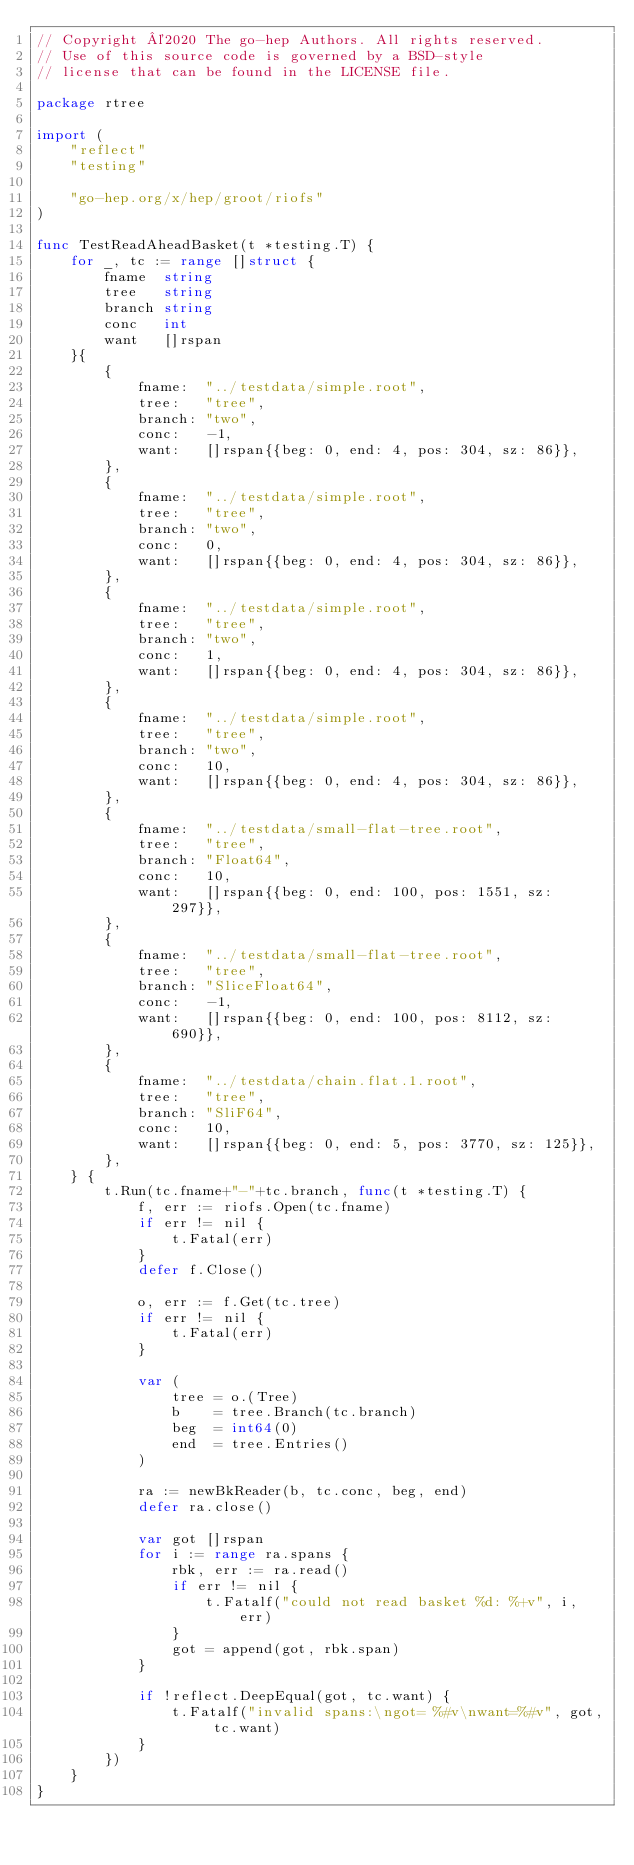<code> <loc_0><loc_0><loc_500><loc_500><_Go_>// Copyright ©2020 The go-hep Authors. All rights reserved.
// Use of this source code is governed by a BSD-style
// license that can be found in the LICENSE file.

package rtree

import (
	"reflect"
	"testing"

	"go-hep.org/x/hep/groot/riofs"
)

func TestReadAheadBasket(t *testing.T) {
	for _, tc := range []struct {
		fname  string
		tree   string
		branch string
		conc   int
		want   []rspan
	}{
		{
			fname:  "../testdata/simple.root",
			tree:   "tree",
			branch: "two",
			conc:   -1,
			want:   []rspan{{beg: 0, end: 4, pos: 304, sz: 86}},
		},
		{
			fname:  "../testdata/simple.root",
			tree:   "tree",
			branch: "two",
			conc:   0,
			want:   []rspan{{beg: 0, end: 4, pos: 304, sz: 86}},
		},
		{
			fname:  "../testdata/simple.root",
			tree:   "tree",
			branch: "two",
			conc:   1,
			want:   []rspan{{beg: 0, end: 4, pos: 304, sz: 86}},
		},
		{
			fname:  "../testdata/simple.root",
			tree:   "tree",
			branch: "two",
			conc:   10,
			want:   []rspan{{beg: 0, end: 4, pos: 304, sz: 86}},
		},
		{
			fname:  "../testdata/small-flat-tree.root",
			tree:   "tree",
			branch: "Float64",
			conc:   10,
			want:   []rspan{{beg: 0, end: 100, pos: 1551, sz: 297}},
		},
		{
			fname:  "../testdata/small-flat-tree.root",
			tree:   "tree",
			branch: "SliceFloat64",
			conc:   -1,
			want:   []rspan{{beg: 0, end: 100, pos: 8112, sz: 690}},
		},
		{
			fname:  "../testdata/chain.flat.1.root",
			tree:   "tree",
			branch: "SliF64",
			conc:   10,
			want:   []rspan{{beg: 0, end: 5, pos: 3770, sz: 125}},
		},
	} {
		t.Run(tc.fname+"-"+tc.branch, func(t *testing.T) {
			f, err := riofs.Open(tc.fname)
			if err != nil {
				t.Fatal(err)
			}
			defer f.Close()

			o, err := f.Get(tc.tree)
			if err != nil {
				t.Fatal(err)
			}

			var (
				tree = o.(Tree)
				b    = tree.Branch(tc.branch)
				beg  = int64(0)
				end  = tree.Entries()
			)

			ra := newBkReader(b, tc.conc, beg, end)
			defer ra.close()

			var got []rspan
			for i := range ra.spans {
				rbk, err := ra.read()
				if err != nil {
					t.Fatalf("could not read basket %d: %+v", i, err)
				}
				got = append(got, rbk.span)
			}

			if !reflect.DeepEqual(got, tc.want) {
				t.Fatalf("invalid spans:\ngot= %#v\nwant=%#v", got, tc.want)
			}
		})
	}
}
</code> 